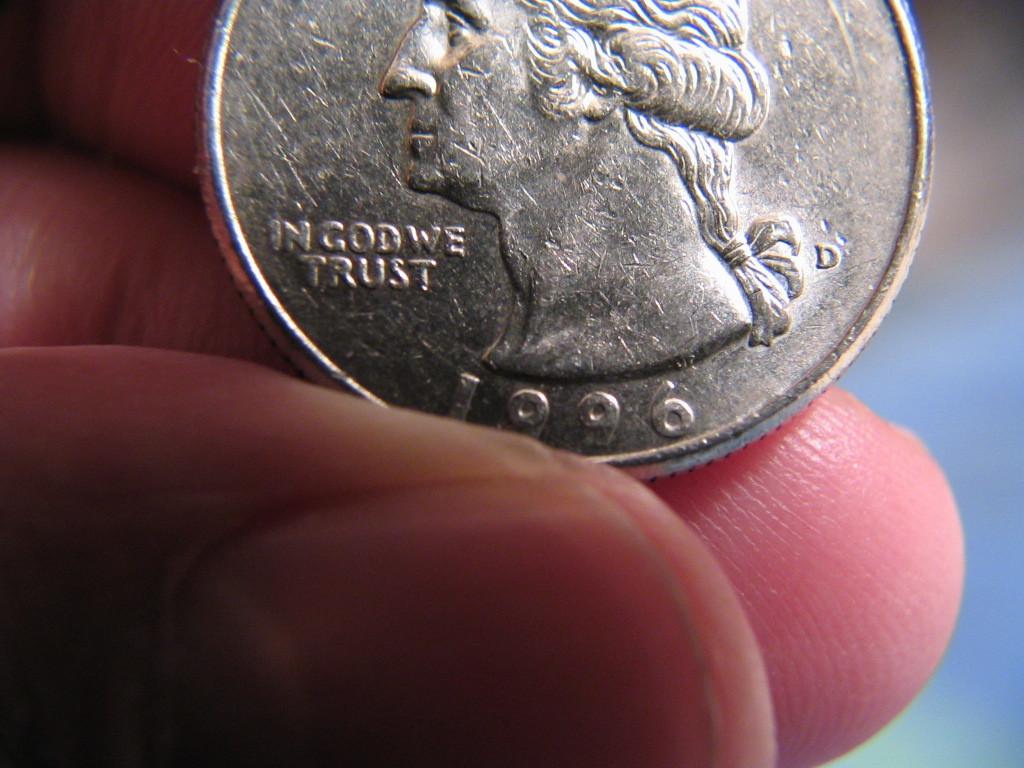What year is on the coin?
Your response must be concise. 1996. 